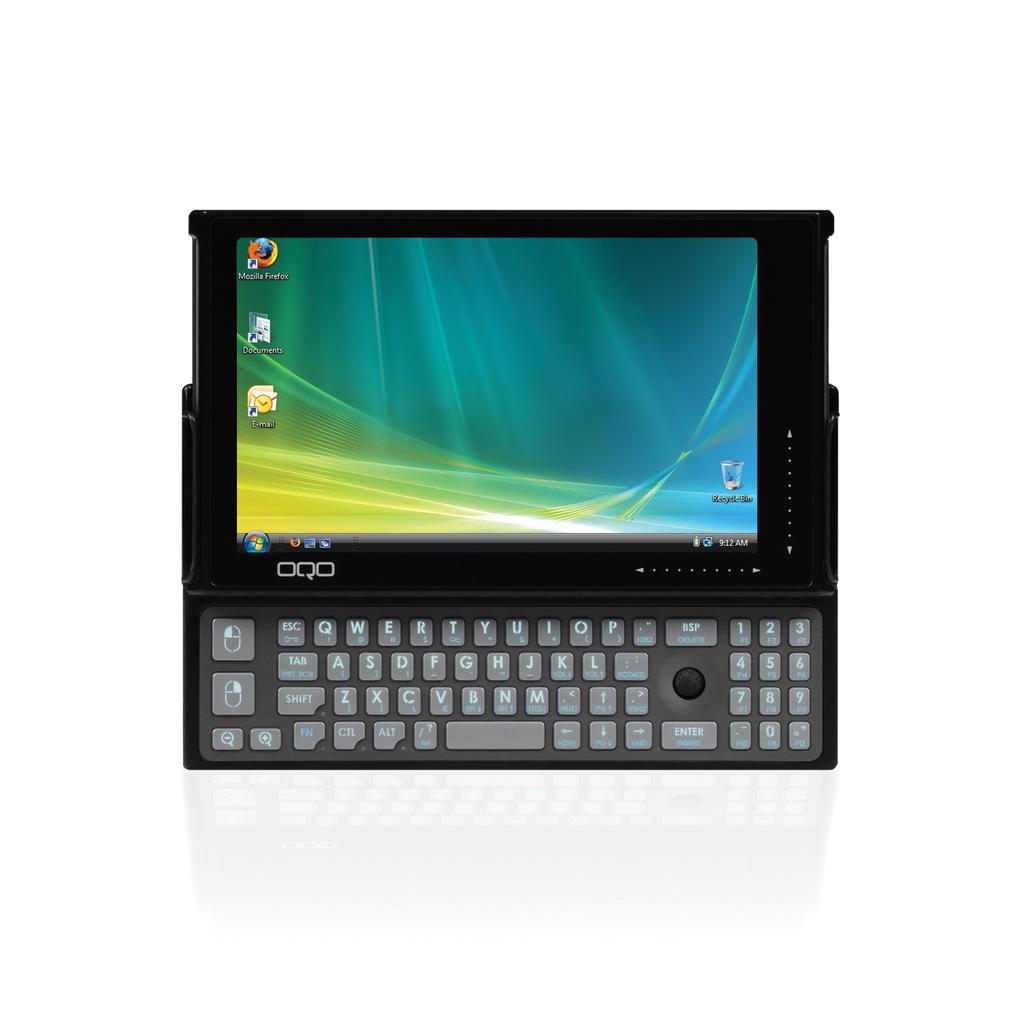What is the brand of phone?
Offer a very short reply. Oqo. 